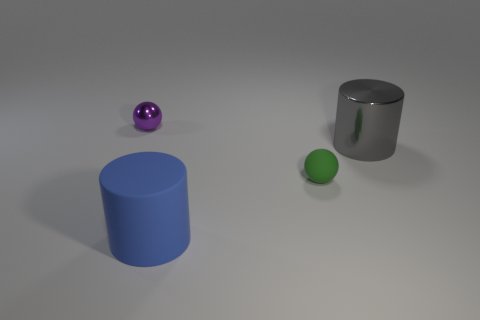What number of large cylinders are on the left side of the large metallic thing?
Ensure brevity in your answer.  1. Do the large gray cylinder and the small thing behind the large shiny thing have the same material?
Make the answer very short. Yes. The gray object that is the same material as the purple object is what size?
Keep it short and to the point. Large. Is the number of green spheres behind the rubber cylinder greater than the number of green objects in front of the rubber ball?
Make the answer very short. Yes. Is there another object of the same shape as the big gray object?
Offer a terse response. Yes. There is a cylinder that is on the left side of the green ball; is its size the same as the small purple sphere?
Provide a succinct answer. No. Is there a brown matte cylinder?
Your response must be concise. No. How many objects are either shiny things right of the tiny rubber thing or big yellow rubber cubes?
Your response must be concise. 1. Are there any other objects of the same size as the purple object?
Offer a terse response. Yes. There is a tiny thing in front of the metal thing that is on the left side of the large gray shiny cylinder; what is it made of?
Your response must be concise. Rubber. 